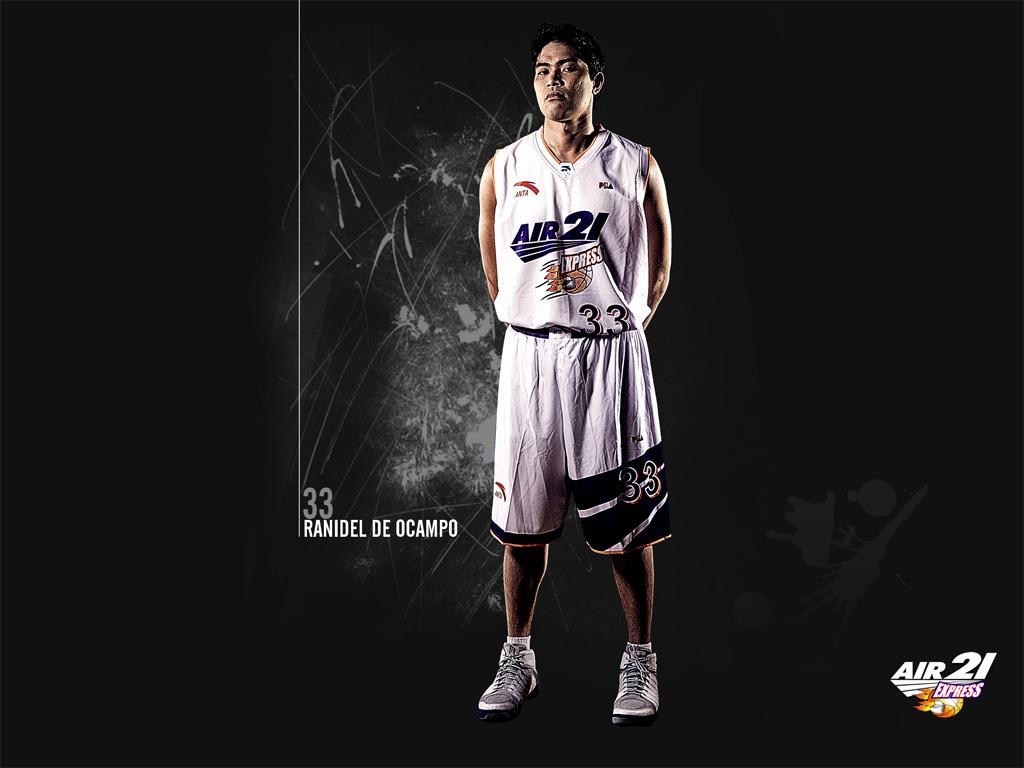Provide a one-sentence caption for the provided image. A basketball player with a Jersey saying Air 21. 